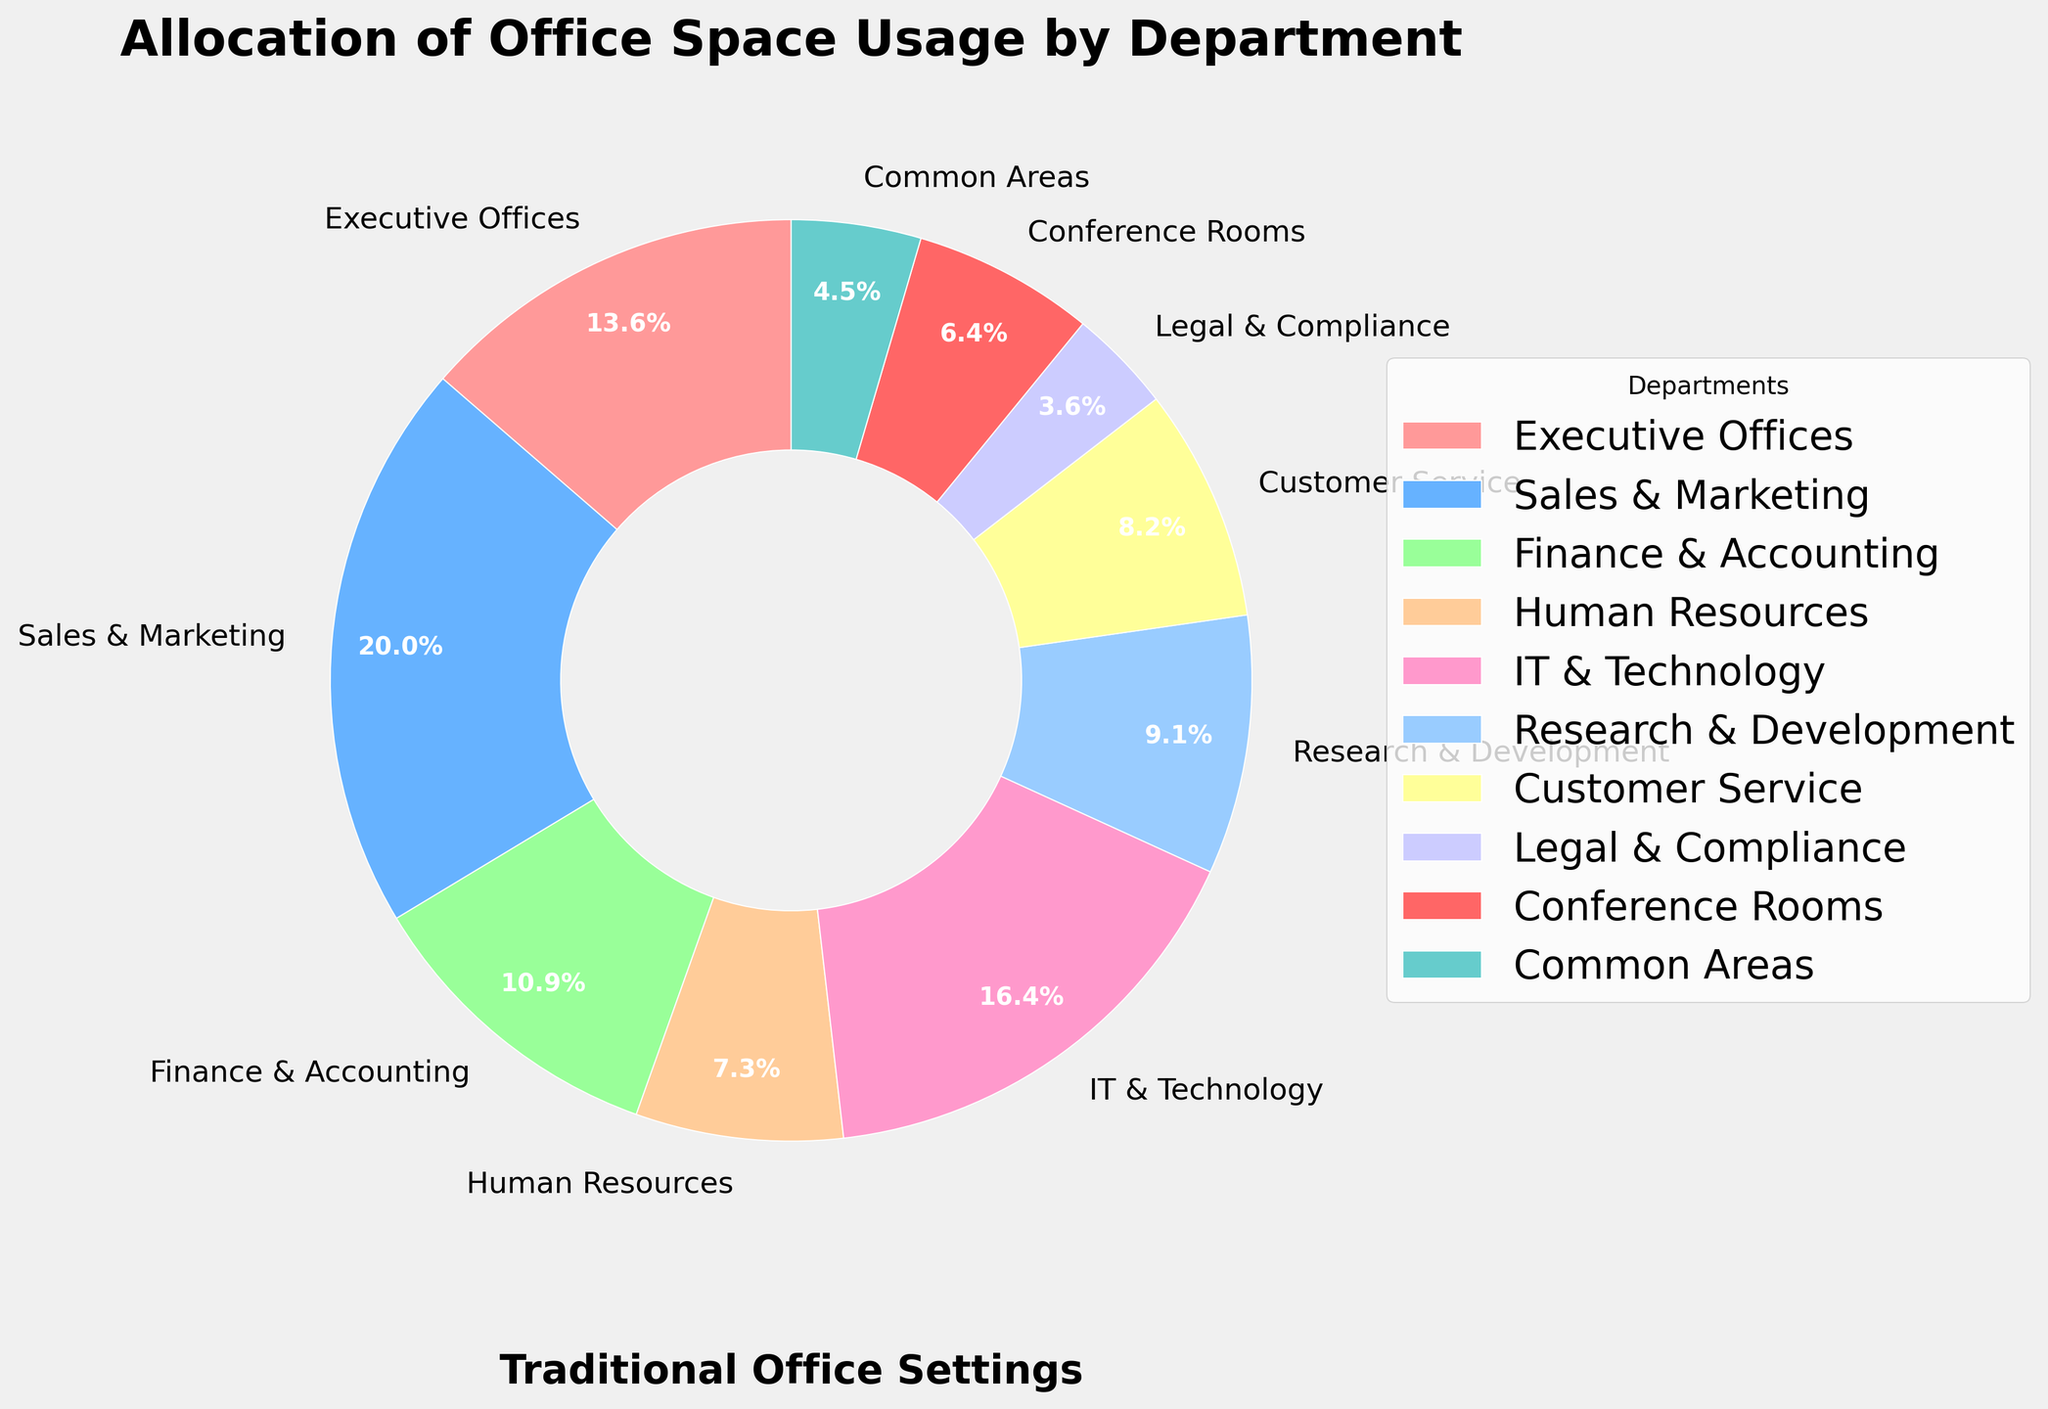Which department uses the largest allocation of office space? By looking at the pie chart, find the segment with the largest percentage. The Sales & Marketing department has a larger segment with 22%.
Answer: Sales & Marketing What is the combined office space allocation for IT & Technology and Research & Development? Find the percentage for IT & Technology (18%) and Research & Development (10%), then add them together: 18% + 10% = 28%.
Answer: 28% Which department uses less office space: Human Resources or Customer Service? Compare the segments for Human Resources (8%) and Customer Service (9%). Human Resources has a smaller percentage.
Answer: Human Resources Is the office space allocated to Executive Offices greater than the combined space allocated to Legal & Compliance and Common Areas? Compare the percentage of Executive Offices (15%) with the sum of Legal & Compliance (4%) and Common Areas (5%). 15% is greater than 4% + 5% = 9%.
Answer: Yes What is the percentage difference between Sales & Marketing and Finance & Accounting? Subtract the percentage of Finance & Accounting (12%) from Sales & Marketing (22%) to find the difference: 22% - 12% = 10%.
Answer: 10% List all departments that use less than 10% of office space. Identify the departments with allocations less than 10%: Human Resources (8%), Customer Service (9%), Legal & Compliance (4%), Conference Rooms (7%), Common Areas (5%).
Answer: Human Resources, Customer Service, Legal & Compliance, Conference Rooms, Common Areas Among the listed departments, which ones are allocated the least office space? Find the department(s) with the smallest percentage. Legal & Compliance has the smallest segment with 4%.
Answer: Legal & Compliance What is the total space allocated to departments with more than 10% space usage? Identify the departments with more than 10%: Executive Offices (15%), Sales & Marketing (22%), Finance & Accounting (12%), IT & Technology (18%). Then sum their percentages: 15% + 22% + 12% + 18% = 67%.
Answer: 67% Which department's office space allocation is represented by the pink segment? Observe the color legend on the pie chart to find which department has the pink color. Executive Offices are represented by a pink segment.
Answer: Executive Offices How much more space is allocated to Sales & Marketing than to Customer Service and Legal & Compliance combined? Calculate the total for Customer Service (9%) and Legal & Compliance (4%): 9% + 4% = 13%. Then, subtract this from Sales & Marketing (22%): 22% - 13% = 9%.
Answer: 9% 